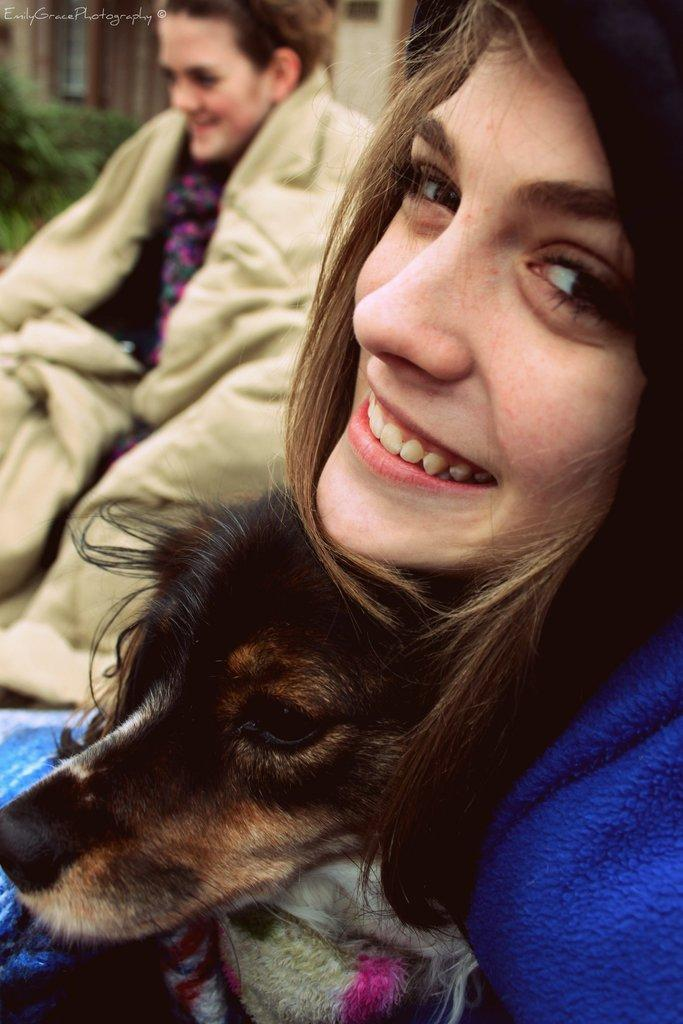How many people are in the image? There are two people in the image. What are the people doing in the image? The people are laughing. What other living creature is present in the image? There is a dog in the image. What time of day does the background of the image suggest? The background of the image suggests morning. What type of flower is being used as a skate by the people in the image? There is no flower or skate present in the image; it features two people laughing and a dog. 